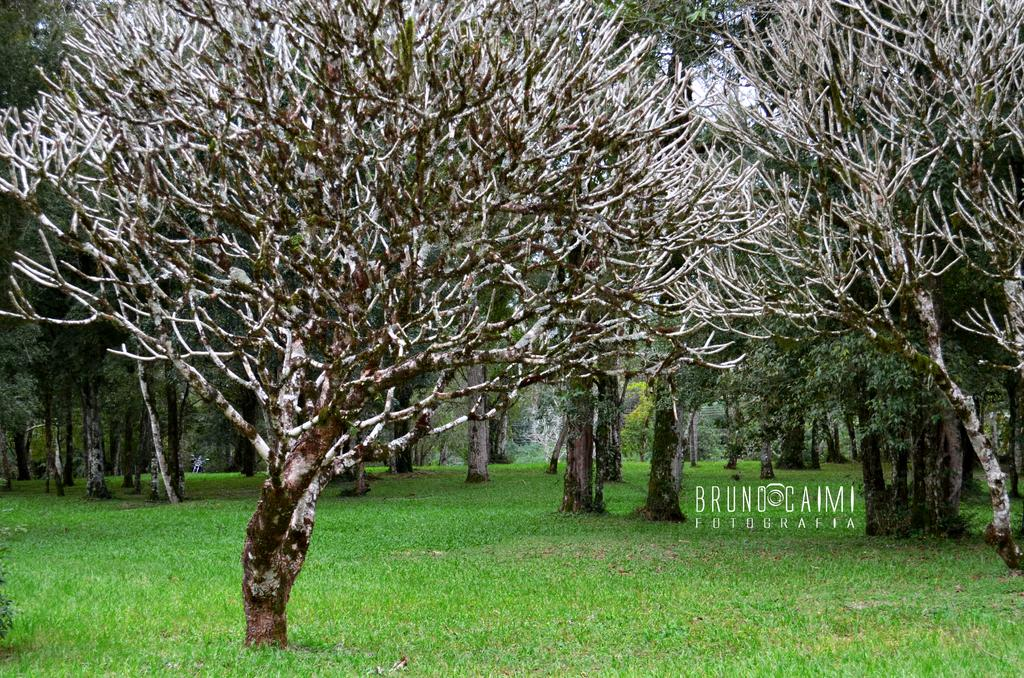What type of vegetation can be seen in the image? There are trees in the image. What is the ground covered with in the image? There is grass on the ground in the image. Can you describe the tree in the foreground? The tree in the foreground is without leaves. Where is the text located in the image? The text is on the right side of the image. What type of apparel is the tree wearing in the image? Trees do not wear apparel, so this question cannot be answered. 